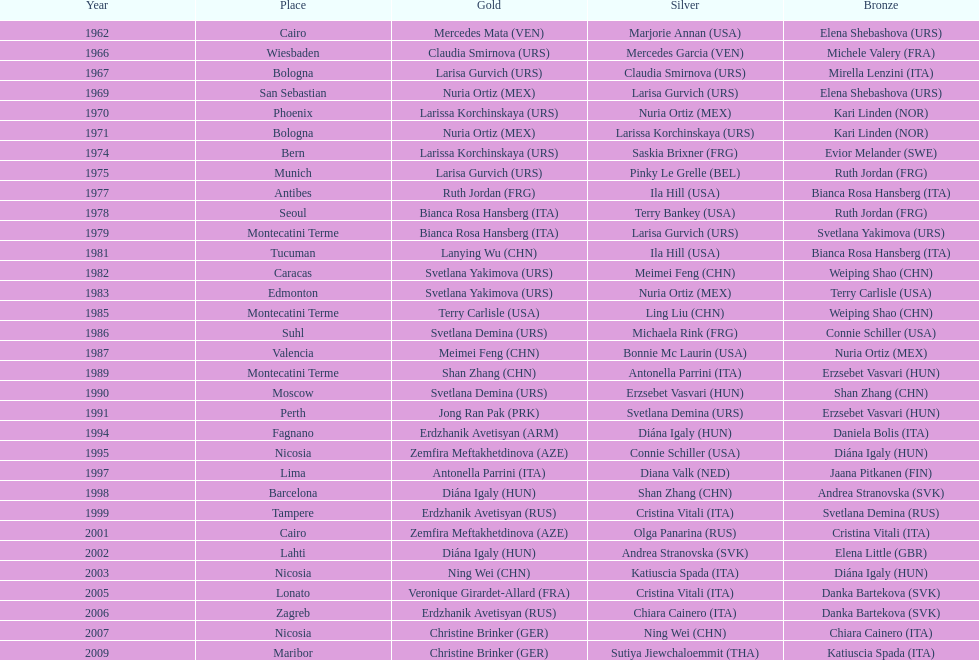What is the overall amount of silver in cairo? 0. 